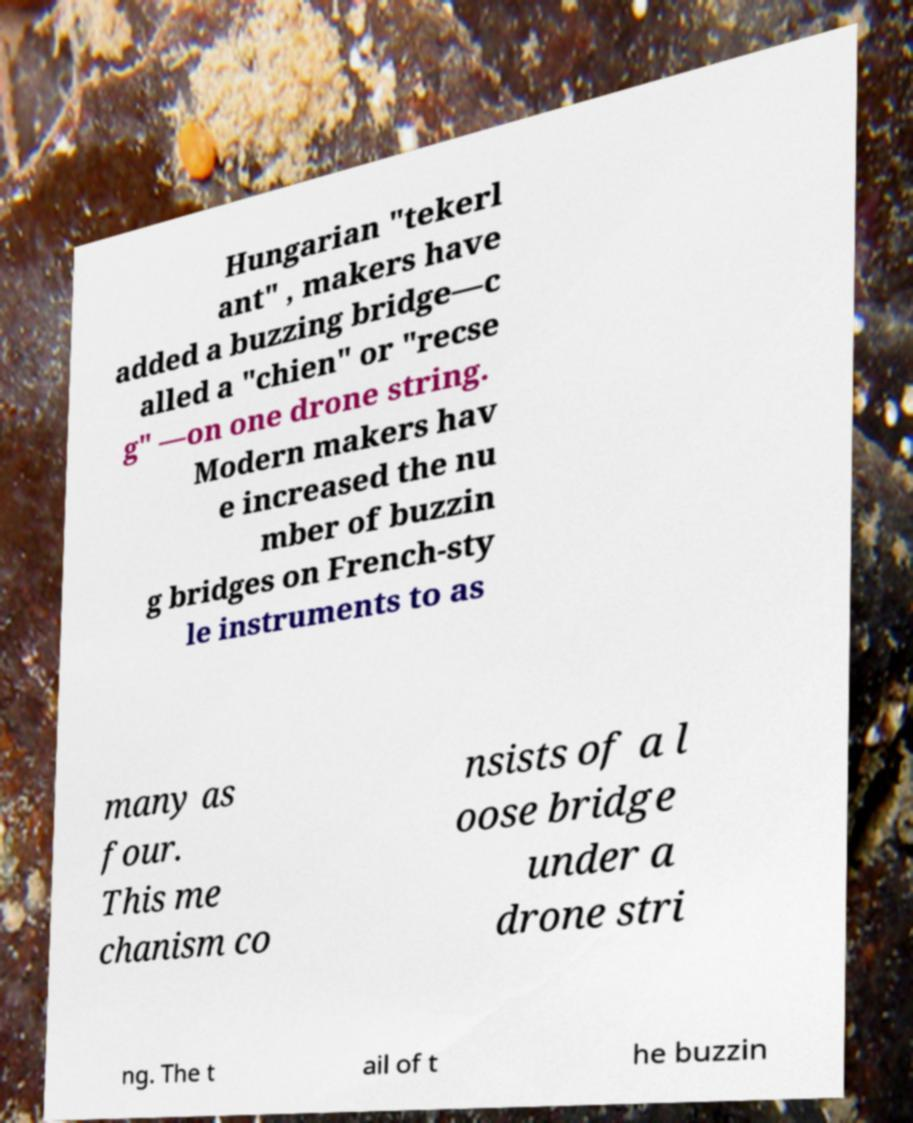What messages or text are displayed in this image? I need them in a readable, typed format. Hungarian "tekerl ant" , makers have added a buzzing bridge—c alled a "chien" or "recse g" —on one drone string. Modern makers hav e increased the nu mber of buzzin g bridges on French-sty le instruments to as many as four. This me chanism co nsists of a l oose bridge under a drone stri ng. The t ail of t he buzzin 